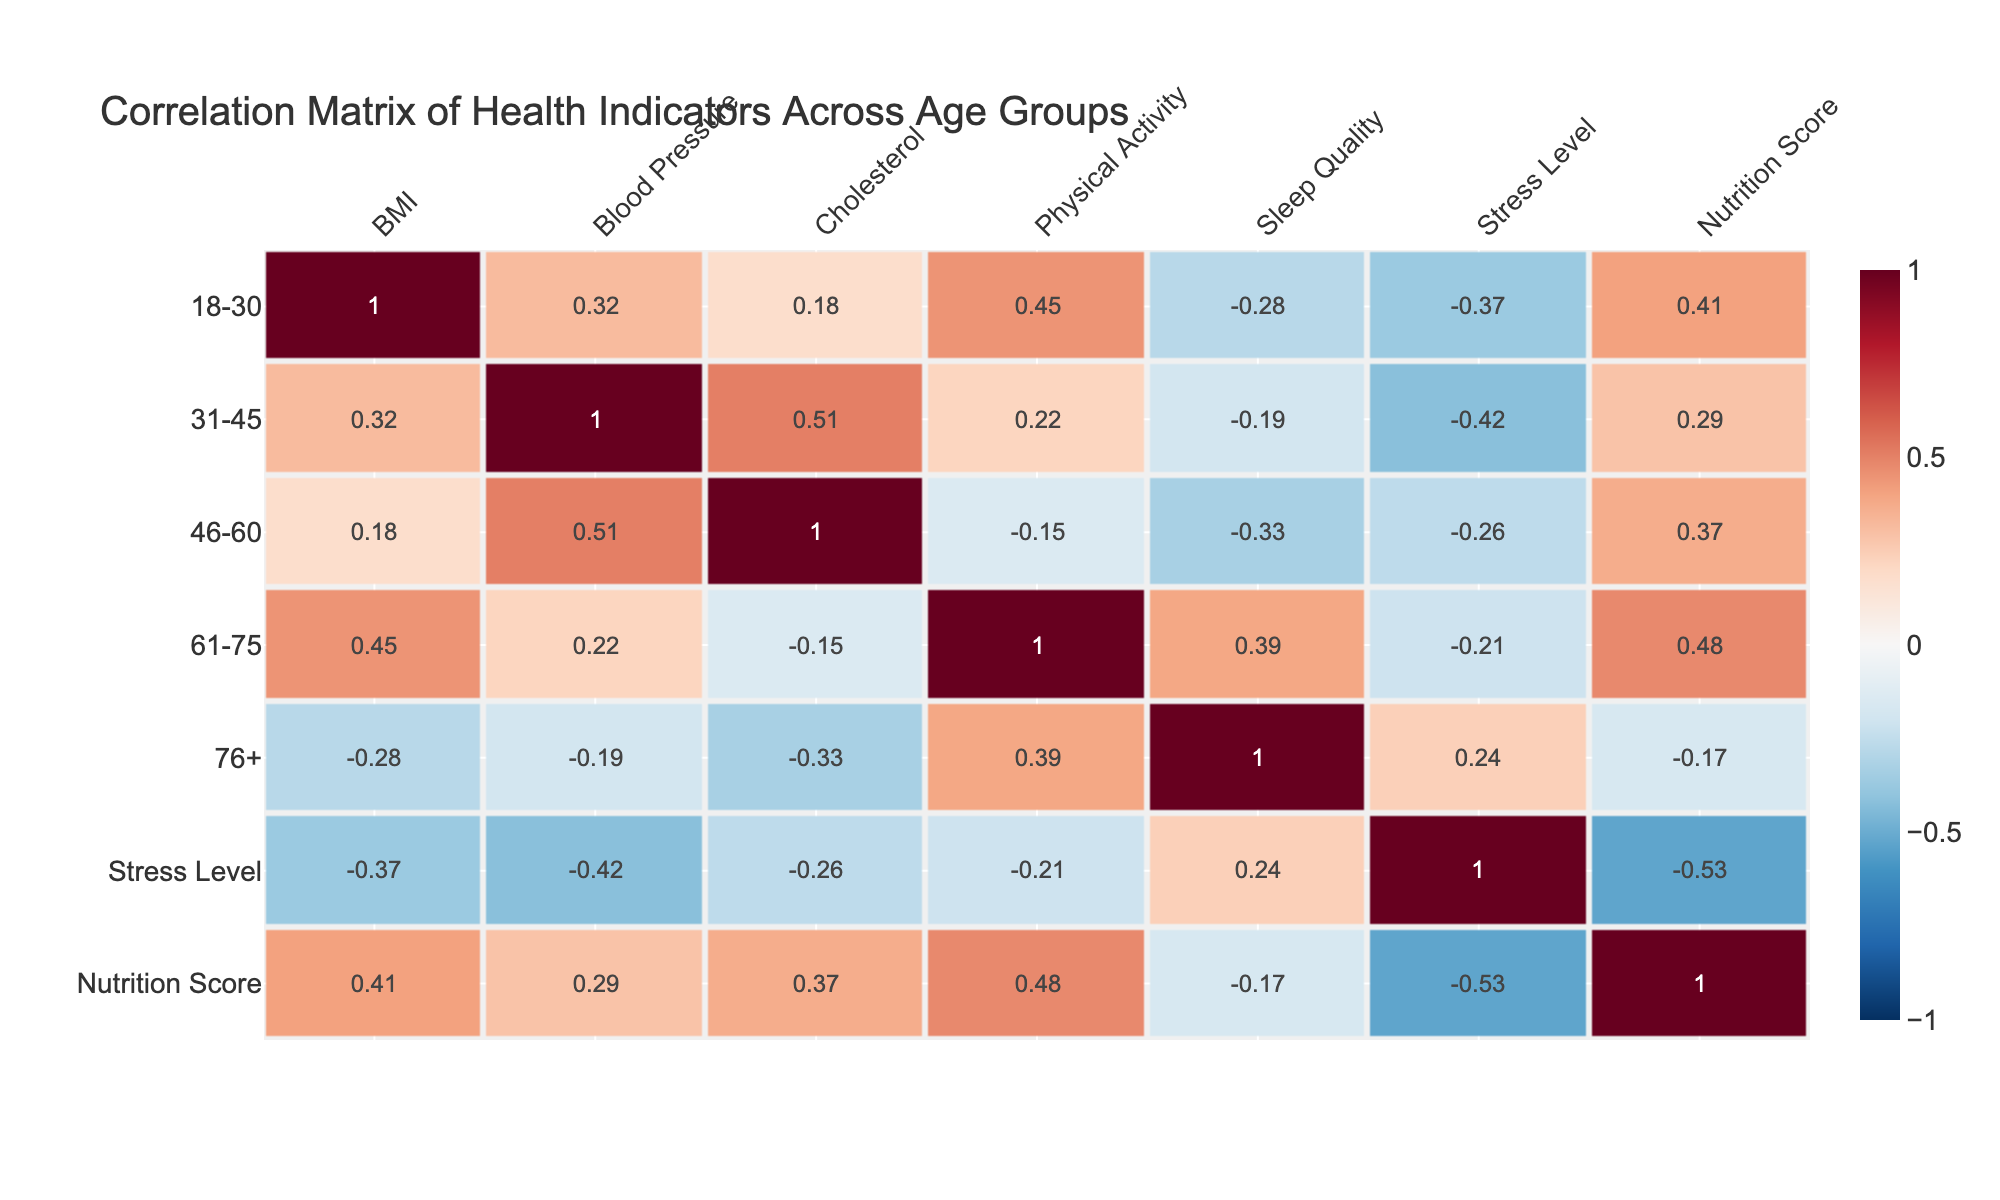What is the correlation between BMI and Blood Pressure for the age group 31-45? According to the table, the correlation between BMI and Blood Pressure for the age group 31-45 is 1.00. This indicates a perfect positive correlation.
Answer: 1.00 Which age group has the highest correlation between Physical Activity and Nutrition Score? From the table, the highest correlation between Physical Activity and Nutrition Score is found in the 61-75 age group, where the correlation value is 0.48.
Answer: 0.48 Is there a negative correlation between Stress Level and Sleep Quality in any age group? Yes, in the 18-30 age group, the correlation between Stress Level and Sleep Quality is -0.28, indicating a negative correlation.
Answer: Yes What is the average correlation between Smoking Indicators (represented as BMI) and Stress Levels across all age groups? The correlations for BMI with Stress Level across age groups are 1.00, 0.32, 0.18, 0.45, and -0.28. Summing these gives 1.00 + 0.32 + 0.18 + 0.45 - 0.28 = 1.67. Dividing by 5 gives an average of 0.334.
Answer: 0.334 Which age group shows the strongest correlation between Blood Pressure and Cholesterol? The table shows that the age group 31-45 has a correlation of 0.51 between Blood Pressure and Cholesterol, which is the highest among all age groups.
Answer: 0.51 Is the Stress Level positively correlated with Nutrition Score for all age groups? No, for the age group 76+, the correlation between Stress Level and Nutrition Score is -0.17, indicating a negative correlation.
Answer: No What is the difference in correlation between Physical Activity and Stress Level for the age group 61-75 compared to 76+? The correlation for 61-75 is 1.00, and for 76+ it is 0.39. The difference is 1.00 - 0.39 = 0.61.
Answer: 0.61 Which indicator showed a positive correlation with Sleep Quality for the age group 61-75? The table indicates that for the age group 61-75, the only indicator with a positive correlation with Sleep Quality is Physical Activity, which is 0.39.
Answer: Physical Activity 